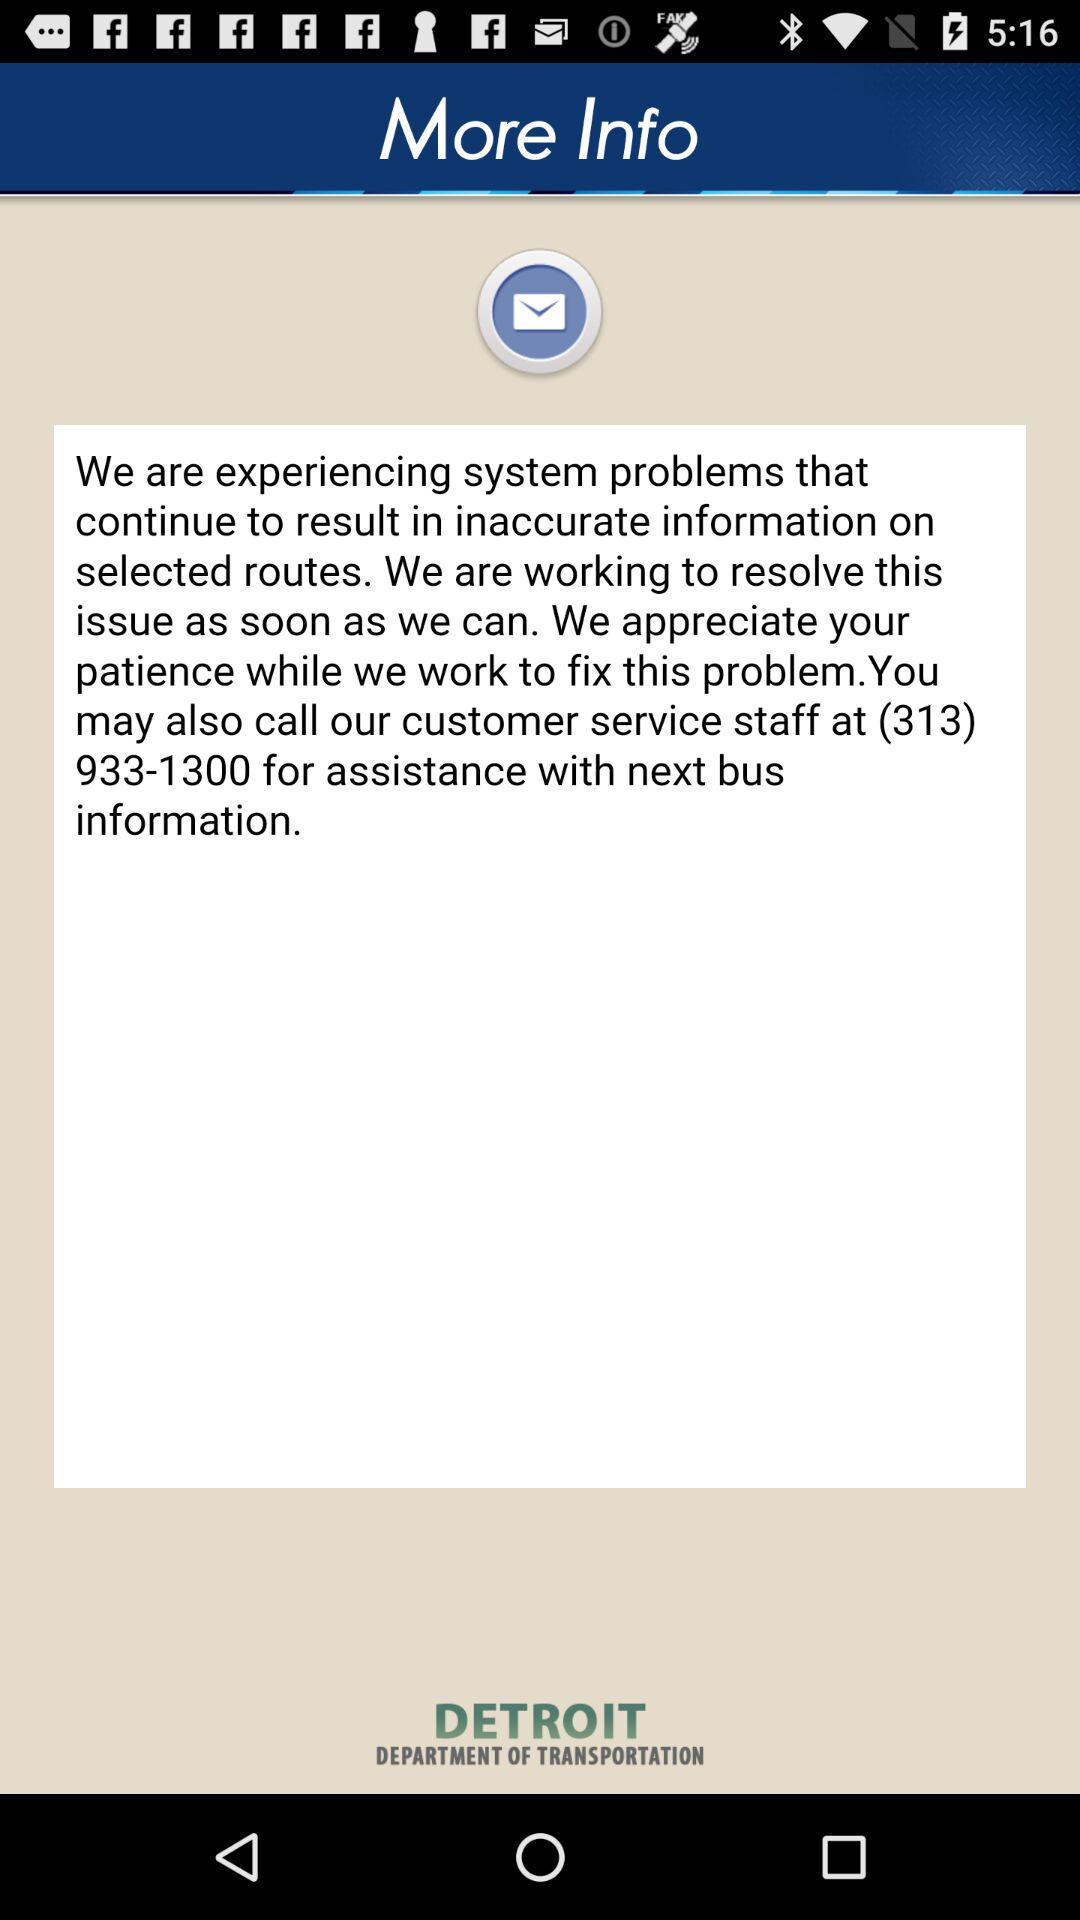What is the customer service contact number? The customer service contact number is (313) 933-1300. 